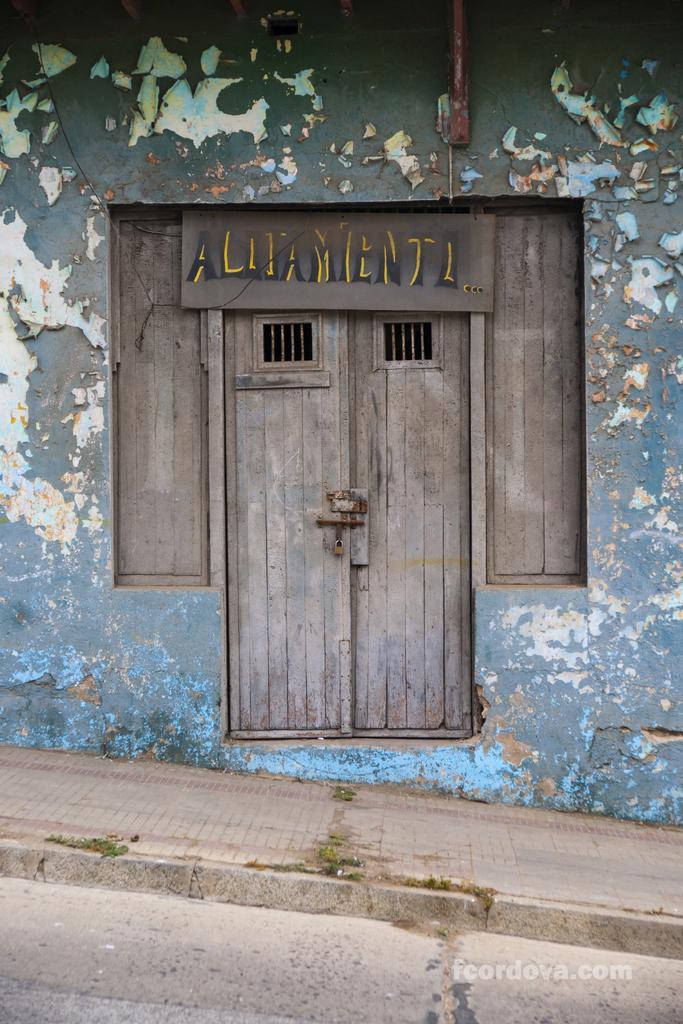Can you describe this image briefly? In this image we can see a door, windows, wall, footpath and road. 